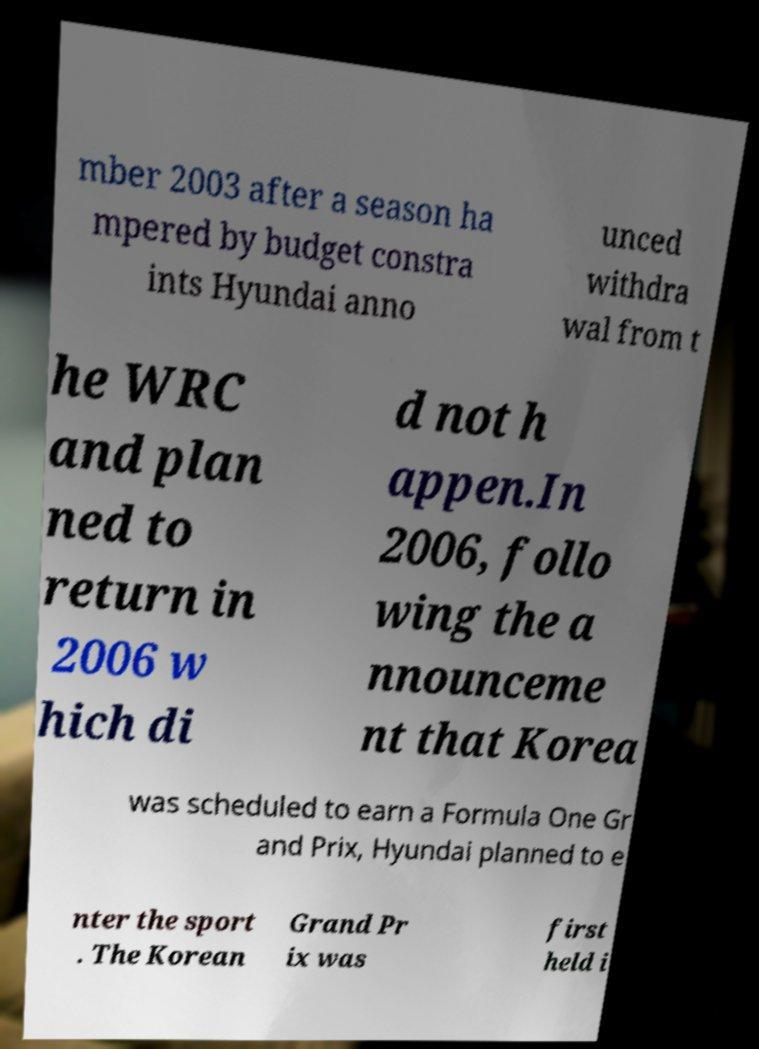What messages or text are displayed in this image? I need them in a readable, typed format. mber 2003 after a season ha mpered by budget constra ints Hyundai anno unced withdra wal from t he WRC and plan ned to return in 2006 w hich di d not h appen.In 2006, follo wing the a nnounceme nt that Korea was scheduled to earn a Formula One Gr and Prix, Hyundai planned to e nter the sport . The Korean Grand Pr ix was first held i 